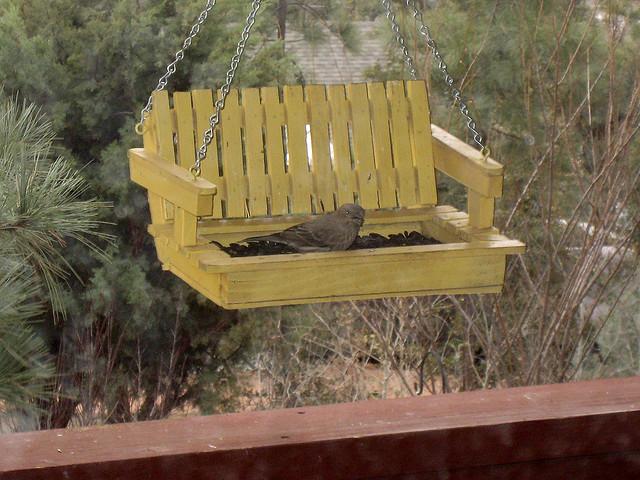Where was this photo taken?
Quick response, please. Outside. Who is sitting on the small bench?
Write a very short answer. Bird. How many birds are on the bird house?
Write a very short answer. 1. How many chains are holding up the bench?
Be succinct. 4. What color is the bench?
Concise answer only. Yellow. 